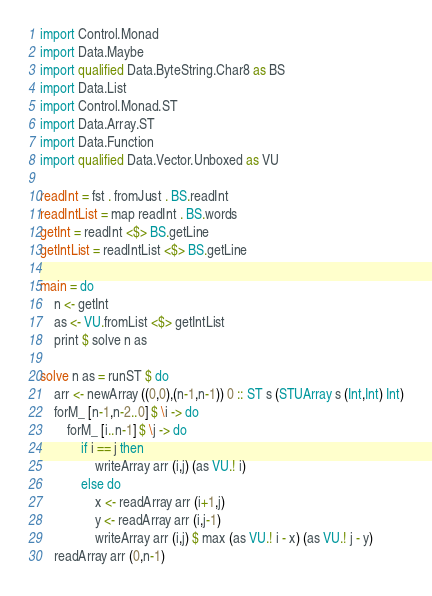Convert code to text. <code><loc_0><loc_0><loc_500><loc_500><_Haskell_>import Control.Monad
import Data.Maybe
import qualified Data.ByteString.Char8 as BS
import Data.List
import Control.Monad.ST
import Data.Array.ST
import Data.Function
import qualified Data.Vector.Unboxed as VU

readInt = fst . fromJust . BS.readInt
readIntList = map readInt . BS.words
getInt = readInt <$> BS.getLine
getIntList = readIntList <$> BS.getLine

main = do
    n <- getInt
    as <- VU.fromList <$> getIntList
    print $ solve n as

solve n as = runST $ do
    arr <- newArray ((0,0),(n-1,n-1)) 0 :: ST s (STUArray s (Int,Int) Int)
    forM_ [n-1,n-2..0] $ \i -> do
        forM_ [i..n-1] $ \j -> do
            if i == j then
                writeArray arr (i,j) (as VU.! i)
            else do
                x <- readArray arr (i+1,j)
                y <- readArray arr (i,j-1)
                writeArray arr (i,j) $ max (as VU.! i - x) (as VU.! j - y)
    readArray arr (0,n-1)</code> 